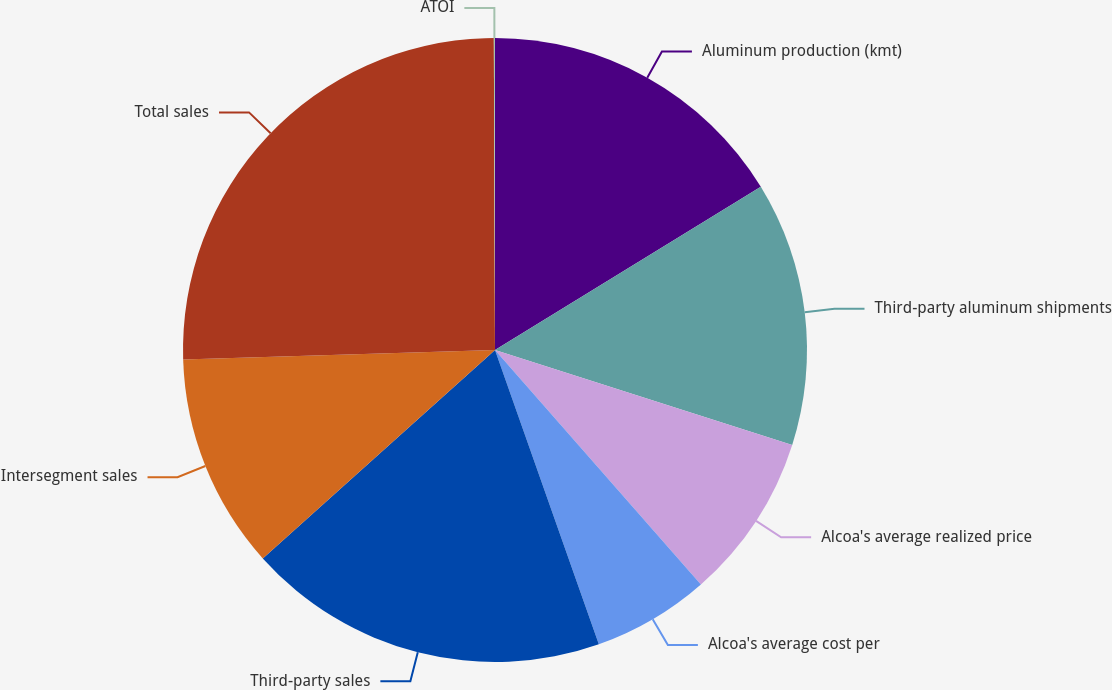Convert chart to OTSL. <chart><loc_0><loc_0><loc_500><loc_500><pie_chart><fcel>Aluminum production (kmt)<fcel>Third-party aluminum shipments<fcel>Alcoa's average realized price<fcel>Alcoa's average cost per<fcel>Third-party sales<fcel>Intersegment sales<fcel>Total sales<fcel>ATOI<nl><fcel>16.23%<fcel>13.69%<fcel>8.61%<fcel>6.07%<fcel>18.76%<fcel>11.15%<fcel>25.43%<fcel>0.06%<nl></chart> 